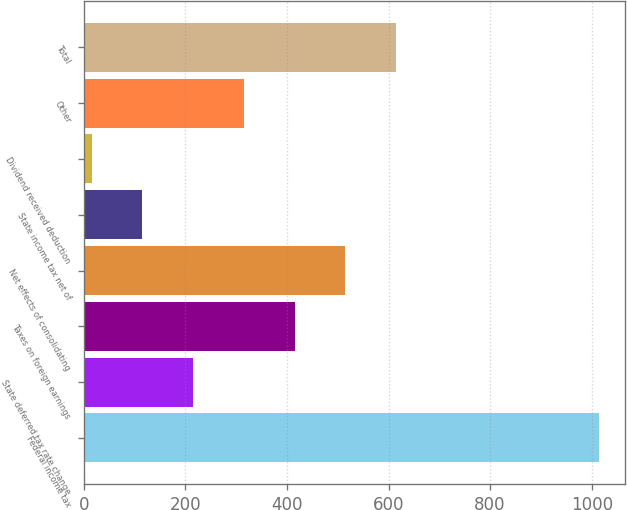Convert chart to OTSL. <chart><loc_0><loc_0><loc_500><loc_500><bar_chart><fcel>Federal income tax<fcel>State deferred tax rate change<fcel>Taxes on foreign earnings<fcel>Net effects of consolidating<fcel>State income tax net of<fcel>Dividend received deduction<fcel>Other<fcel>Total<nl><fcel>1014.3<fcel>215.34<fcel>415.08<fcel>514.95<fcel>115.47<fcel>15.6<fcel>315.21<fcel>614.82<nl></chart> 